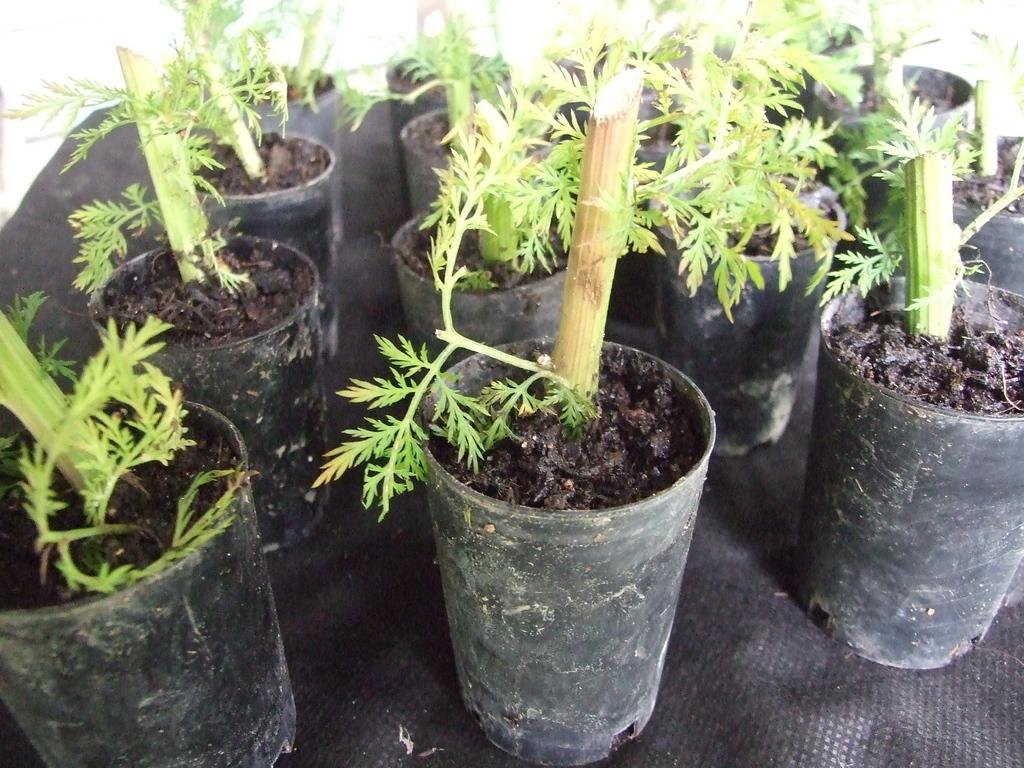What type of objects can be seen in the image? There are many potted plants in the image. Can you describe the arrangement of the potted plants? The arrangement of the potted plants cannot be determined from the provided facts. What type of plants are in the pots? The type of plants in the pots cannot be determined from the provided facts. What type of canvas is being used to paint a rock in the lunchroom in the image? There is no canvas, rock, or lunchroom present in the image; it only contains potted plants. 